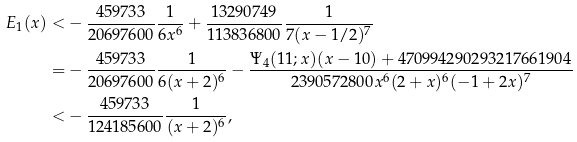Convert formula to latex. <formula><loc_0><loc_0><loc_500><loc_500>E _ { 1 } ( x ) < & - \frac { 4 5 9 7 3 3 } { 2 0 6 9 7 6 0 0 } \frac { 1 } { 6 x ^ { 6 } } + \frac { 1 3 2 9 0 7 4 9 } { 1 1 3 8 3 6 8 0 0 } \frac { 1 } { 7 ( x - 1 / 2 ) ^ { 7 } } \\ = & - \frac { 4 5 9 7 3 3 } { 2 0 6 9 7 6 0 0 } \frac { 1 } { 6 ( x + 2 ) ^ { 6 } } - \frac { \Psi _ { 4 } ( 1 1 ; x ) ( x - 1 0 ) + 4 7 0 9 9 4 2 9 0 2 9 3 2 1 7 6 6 1 9 0 4 } { 2 3 9 0 5 7 2 8 0 0 x ^ { 6 } ( 2 + x ) ^ { 6 } ( - 1 + 2 x ) ^ { 7 } } \\ < & - \frac { 4 5 9 7 3 3 } { 1 2 4 1 8 5 6 0 0 } \frac { 1 } { ( x + 2 ) ^ { 6 } } ,</formula> 